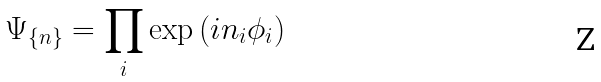Convert formula to latex. <formula><loc_0><loc_0><loc_500><loc_500>\Psi _ { \{ n \} } = \prod _ { i } \exp \left ( i n _ { i } \phi _ { i } \right )</formula> 